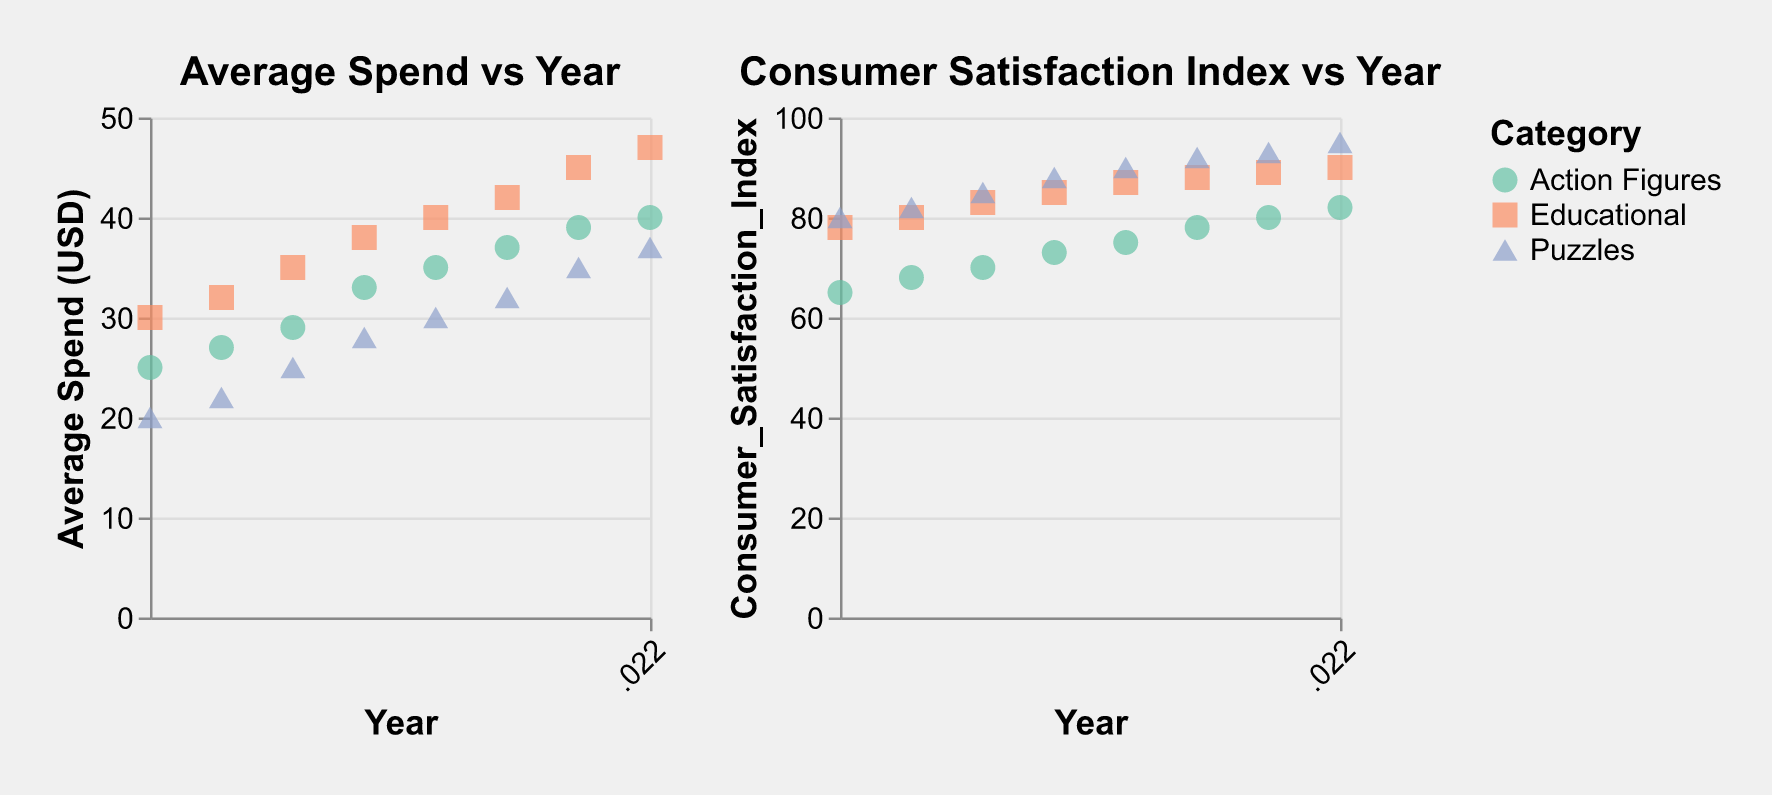What's the average spend on Action Figures in the year 2020? Look at the "Average Spend vs Year" plot, locate the year 2020 on the x-axis, then find the value of the Action Figures data point on the y-axis for average spend
Answer: 37 USD What is the trend in consumer satisfaction for Educational toys from 2015 to 2022? Examine the "Consumer Satisfaction Index vs Year" plot, follow the Educational category from 2015 to 2022, and observe the upward trend of satisfaction values
Answer: Increasing Which category had the highest consumer satisfaction in 2022? In the "Consumer Satisfaction Index vs Year" plot, check the data points for the year 2022 and compare the indices of each category
Answer: Puzzles Compare the average spend on Puzzles and Action Figures in 2017. Which one is higher? For the year 2017 in the "Average Spend vs Year" plot, compare the average spend values for Puzzles and Action Figures
Answer: Action Figures What is the overall trend in average spend for Educational toys over the years? Refer to the "Average Spend vs Year" plot for the Educational category from 2015 to 2022, observing the progression of plotted points
Answer: Increasing Calculate the difference in consumer satisfaction index between Action Figures and Puzzles in 2019. In the "Consumer Satisfaction Index vs Year" plot, find the satisfaction values for Action Figures (75) and Puzzles (90) in 2019, then subtract the former from the latter
Answer: 15 Identify the year when the consumer satisfaction for Puzzles first exceeded 90. Look at the "Consumer Satisfaction Index vs Year" plot, follow the Puzzles category line, and find the first year where the satisfaction index surpasses 90
Answer: 2019 What was the average consumer satisfaction for Educational toys from 2015 to 2017? Find the satisfaction indices for Education toys from 2015 (78), 2016 (80), and 2017 (83) in the "Consumer Satisfaction Index vs Year" plot, then calculate the average: (78+80+83)/3
Answer: 80.33 How does the consumer satisfaction for Action Figures in 2016 compare to that in 2022? Check the consumer satisfaction values for Action Figures in 2016 (68) and 2022 (82) in the "Consumer Satisfaction Index vs Year" plot, then compare these values
Answer: The satisfaction has increased What is the difference in average spend between Puzzles and Educational toys in 2021? Refer to the "Average Spend vs Year" plot, locate the average spend for Puzzles (35 USD) and Educational toys (45 USD) in 2021, and calculate the difference
Answer: 10 USD 